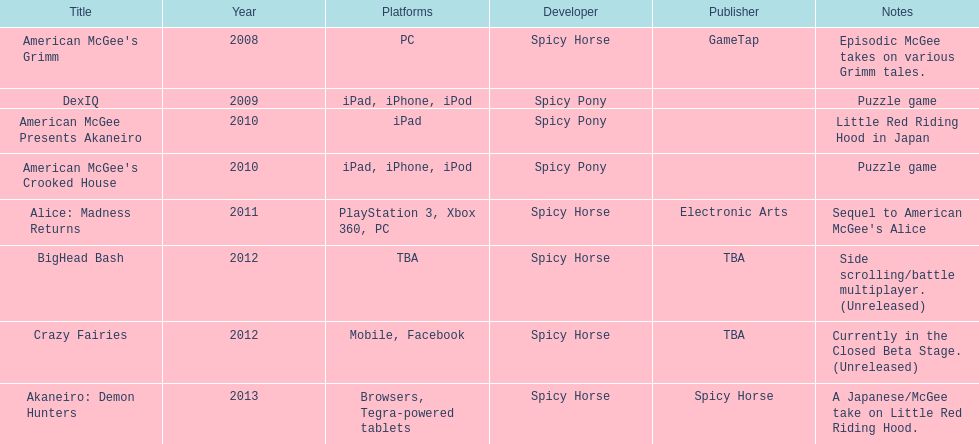According to the table, what is the last title that spicy horse produced? Akaneiro: Demon Hunters. I'm looking to parse the entire table for insights. Could you assist me with that? {'header': ['Title', 'Year', 'Platforms', 'Developer', 'Publisher', 'Notes'], 'rows': [["American McGee's Grimm", '2008', 'PC', 'Spicy Horse', 'GameTap', 'Episodic McGee takes on various Grimm tales.'], ['DexIQ', '2009', 'iPad, iPhone, iPod', 'Spicy Pony', '', 'Puzzle game'], ['American McGee Presents Akaneiro', '2010', 'iPad', 'Spicy Pony', '', 'Little Red Riding Hood in Japan'], ["American McGee's Crooked House", '2010', 'iPad, iPhone, iPod', 'Spicy Pony', '', 'Puzzle game'], ['Alice: Madness Returns', '2011', 'PlayStation 3, Xbox 360, PC', 'Spicy Horse', 'Electronic Arts', "Sequel to American McGee's Alice"], ['BigHead Bash', '2012', 'TBA', 'Spicy Horse', 'TBA', 'Side scrolling/battle multiplayer. (Unreleased)'], ['Crazy Fairies', '2012', 'Mobile, Facebook', 'Spicy Horse', 'TBA', 'Currently in the Closed Beta Stage. (Unreleased)'], ['Akaneiro: Demon Hunters', '2013', 'Browsers, Tegra-powered tablets', 'Spicy Horse', 'Spicy Horse', 'A Japanese/McGee take on Little Red Riding Hood.']]} 